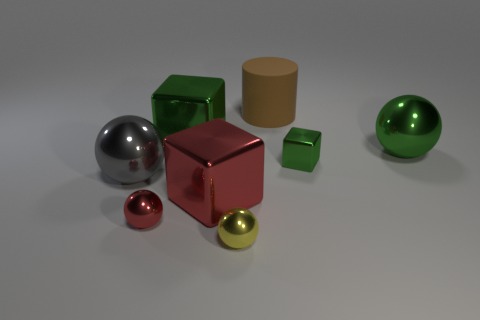What could be the possible use of these objects, assuming they're real and functional? If these objects were real and functional, they might serve as geometrical teaching tools to demonstrate shapes and volume in an educational context. Their varied sizes and colors could make them effective for visual learning. Additionally, if they were scaled appropriately, some of them could serve as containers or decorative items. 